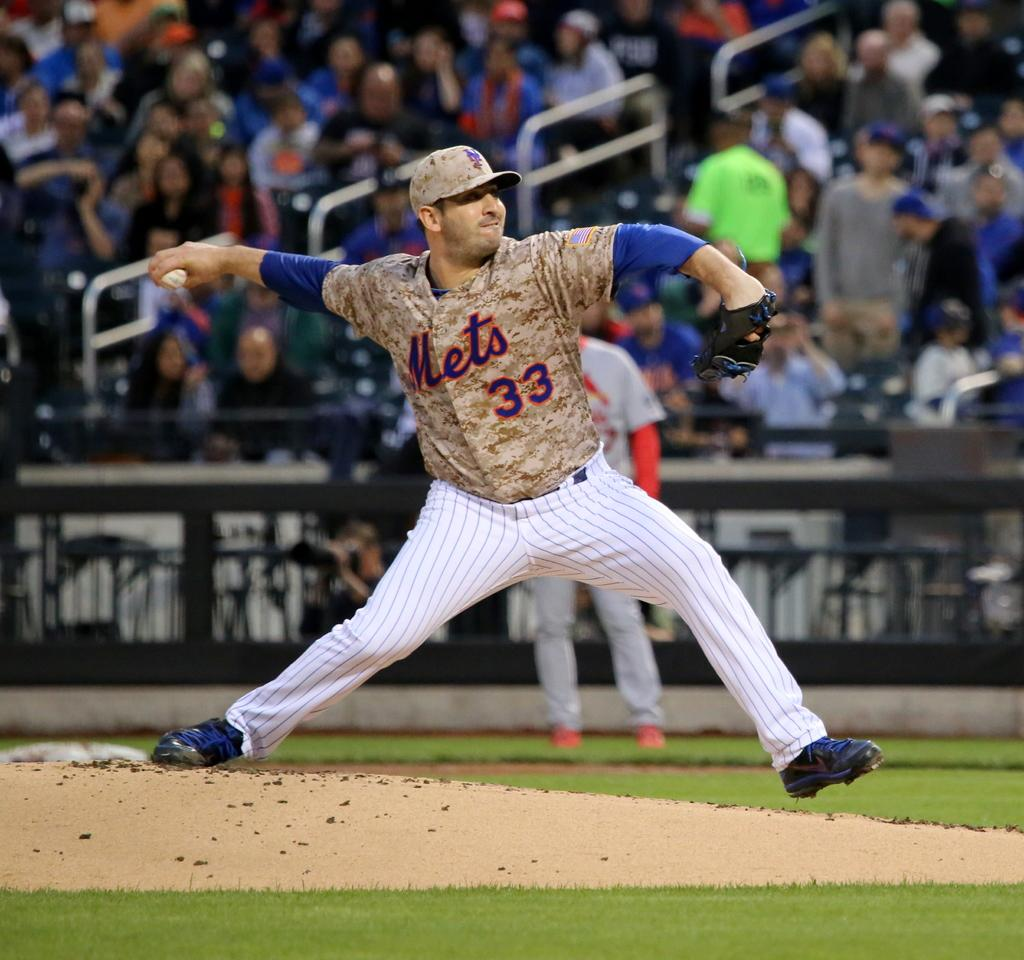<image>
Write a terse but informative summary of the picture. a Mets player getting ready to throw a ball 